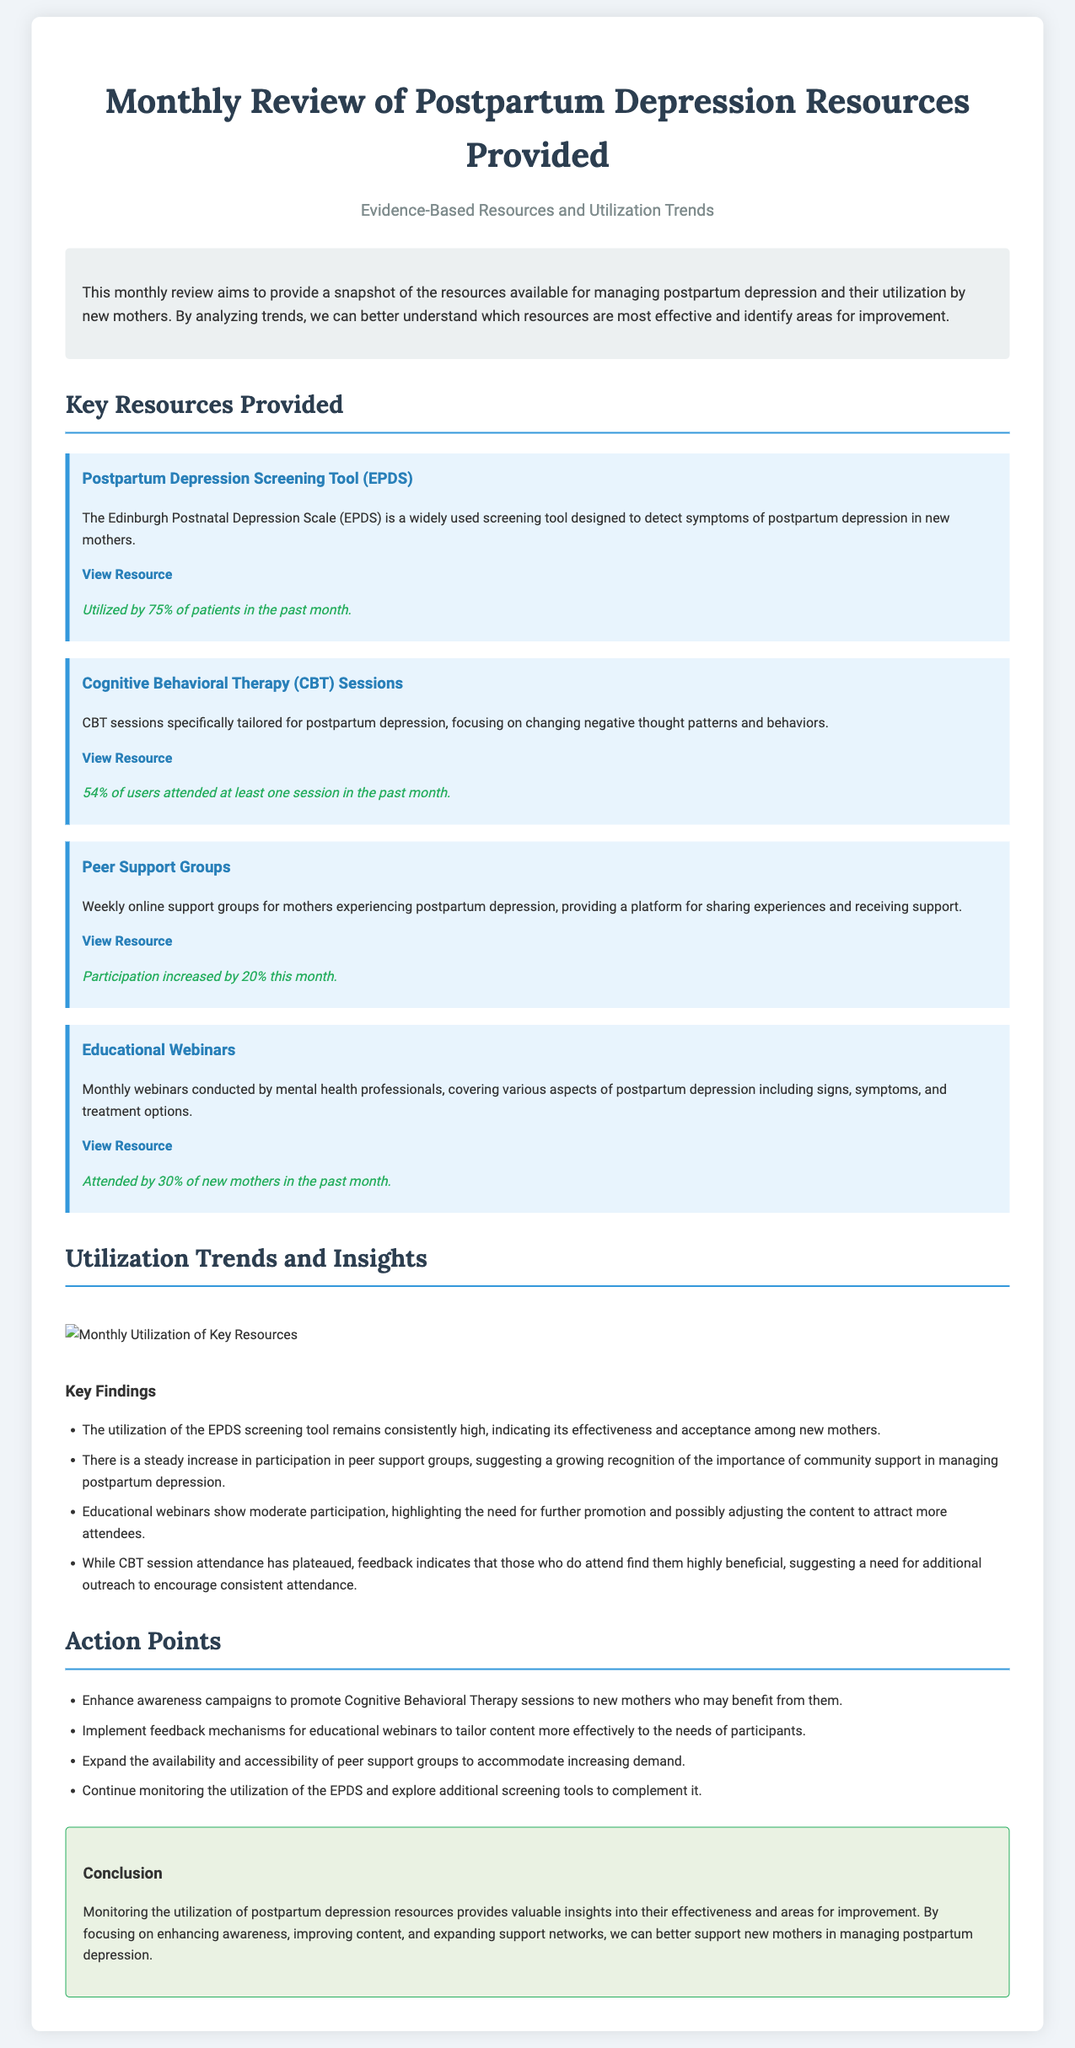What is the title of the document? The title is prominently displayed at the top of the document, stating the focus of the review.
Answer: Monthly Review of Postpartum Depression Resources Provided What percentage of patients utilized the EPDS screening tool? The specific utilization figure is mentioned in the description of the EPDS resource.
Answer: 75% What type of therapy sessions are mentioned in the resources? The resource section specifically references a type of therapy aimed at addressing postpartum depression.
Answer: Cognitive Behavioral Therapy By how much did participation in peer support groups increase this month? The document indicates the change in participation levels for this particular resource.
Answer: 20% What percentage of new mothers attended the educational webinars in the past month? The relevant statistic for webinar attendance is provided in the descriptions of the educational webinars.
Answer: 30% Which resource had the highest utilization among the ones listed? By comparing the utilization rates mentioned for each resource, this can be determined.
Answer: Postpartum Depression Screening Tool (EPDS) What is one action point suggested for enhancing resource utilization? The document lists several action points aimed at improving resource engagement and outreach.
Answer: Enhance awareness campaigns What is the color theme for the document background? The overall background color is described in the styling section of the code.
Answer: #f0f4f8 What are the insights regarding CBT session attendance? This insight is included to reflect on the effectiveness of the CBT sessions based on user feedback.
Answer: Attendance has plateaued 